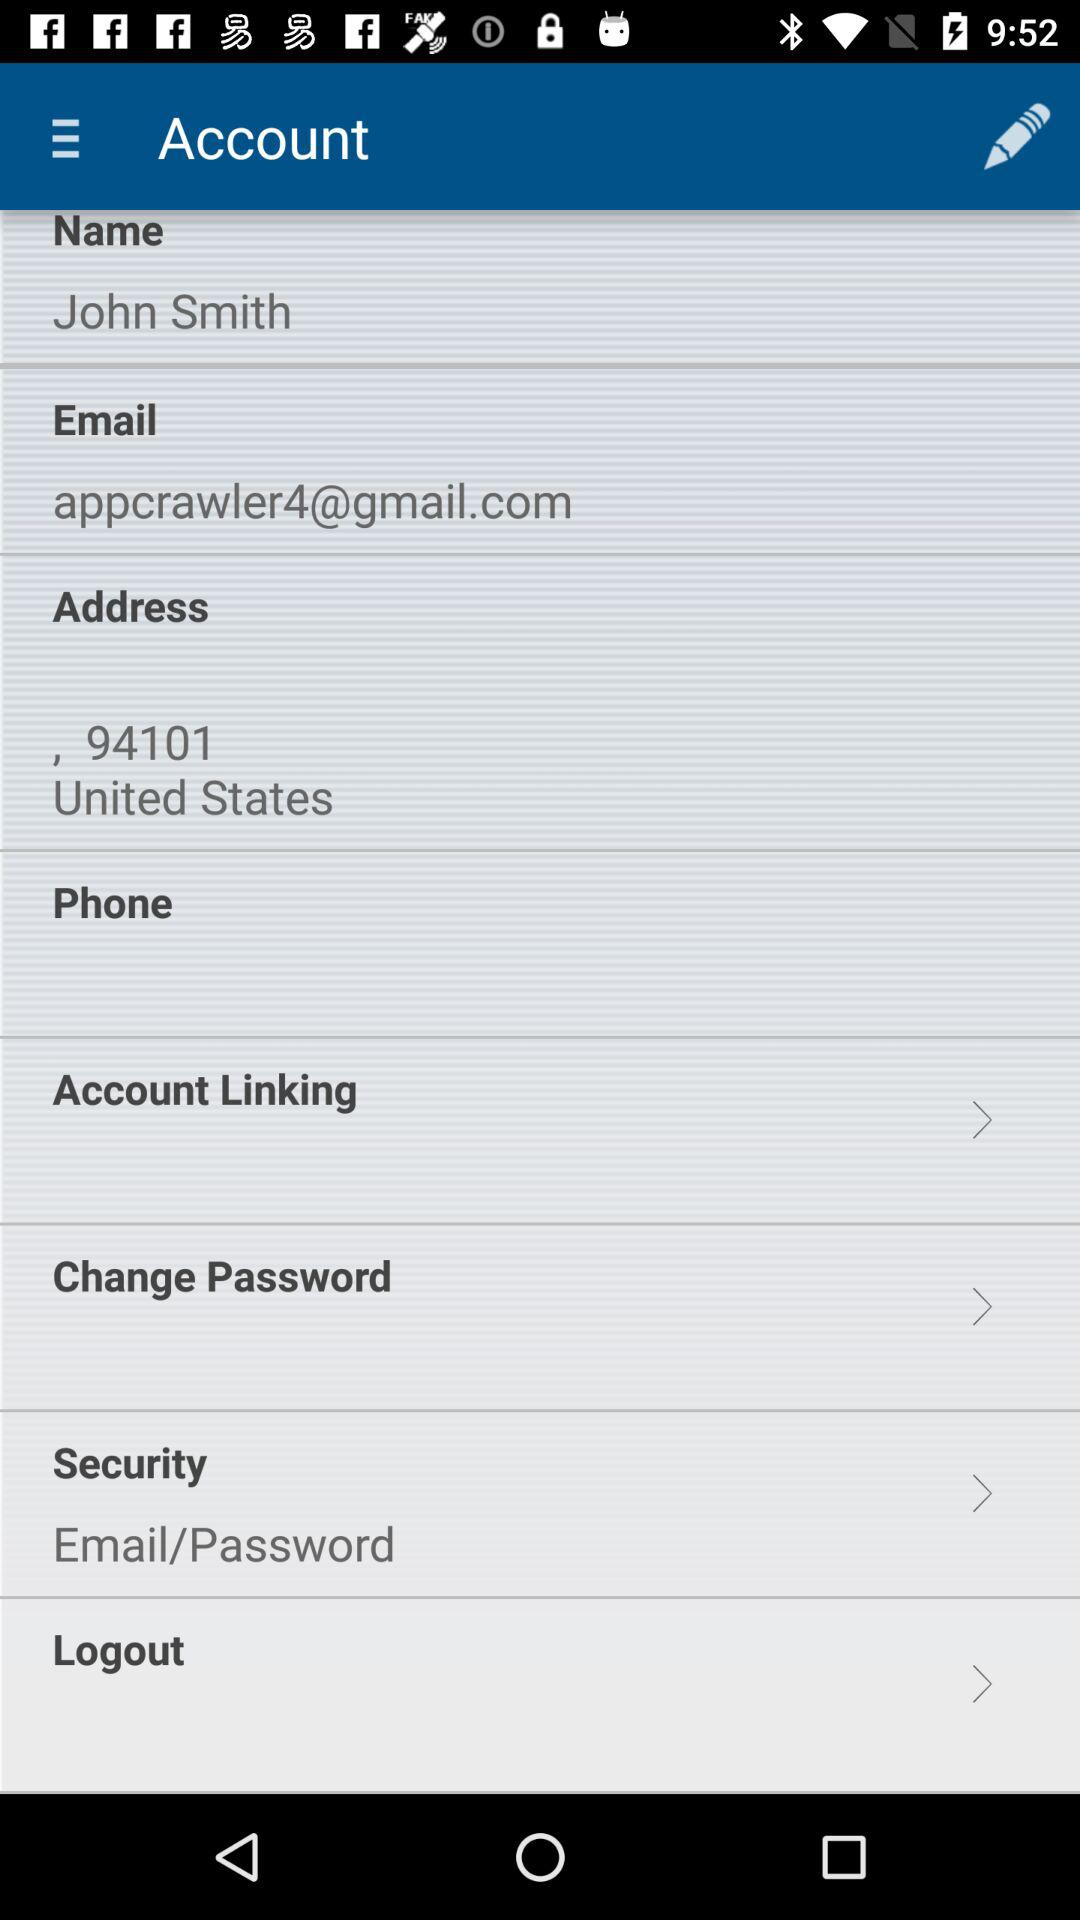What is the email address? The email address is appcrawler4@gmail.com. 